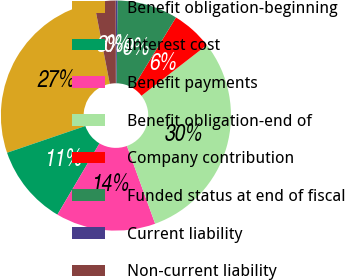Convert chart to OTSL. <chart><loc_0><loc_0><loc_500><loc_500><pie_chart><fcel>Benefit obligation-beginning<fcel>Interest cost<fcel>Benefit payments<fcel>Benefit obligation-end of<fcel>Company contribution<fcel>Funded status at end of fiscal<fcel>Current liability<fcel>Non-current liability<nl><fcel>27.2%<fcel>11.27%<fcel>14.03%<fcel>29.96%<fcel>5.76%<fcel>8.52%<fcel>0.25%<fcel>3.01%<nl></chart> 